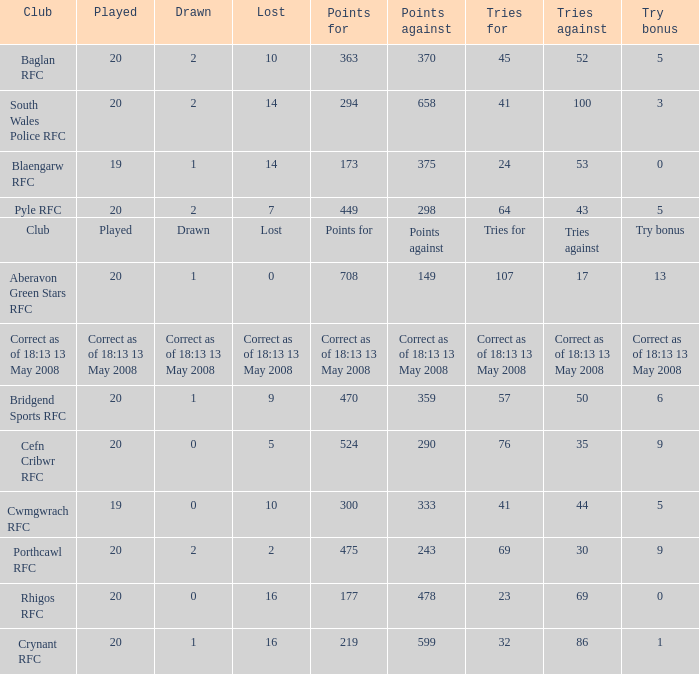Could you parse the entire table as a dict? {'header': ['Club', 'Played', 'Drawn', 'Lost', 'Points for', 'Points against', 'Tries for', 'Tries against', 'Try bonus'], 'rows': [['Baglan RFC', '20', '2', '10', '363', '370', '45', '52', '5'], ['South Wales Police RFC', '20', '2', '14', '294', '658', '41', '100', '3'], ['Blaengarw RFC', '19', '1', '14', '173', '375', '24', '53', '0'], ['Pyle RFC', '20', '2', '7', '449', '298', '64', '43', '5'], ['Club', 'Played', 'Drawn', 'Lost', 'Points for', 'Points against', 'Tries for', 'Tries against', 'Try bonus'], ['Aberavon Green Stars RFC', '20', '1', '0', '708', '149', '107', '17', '13'], ['Correct as of 18:13 13 May 2008', 'Correct as of 18:13 13 May 2008', 'Correct as of 18:13 13 May 2008', 'Correct as of 18:13 13 May 2008', 'Correct as of 18:13 13 May 2008', 'Correct as of 18:13 13 May 2008', 'Correct as of 18:13 13 May 2008', 'Correct as of 18:13 13 May 2008', 'Correct as of 18:13 13 May 2008'], ['Bridgend Sports RFC', '20', '1', '9', '470', '359', '57', '50', '6'], ['Cefn Cribwr RFC', '20', '0', '5', '524', '290', '76', '35', '9'], ['Cwmgwrach RFC', '19', '0', '10', '300', '333', '41', '44', '5'], ['Porthcawl RFC', '20', '2', '2', '475', '243', '69', '30', '9'], ['Rhigos RFC', '20', '0', '16', '177', '478', '23', '69', '0'], ['Crynant RFC', '20', '1', '16', '219', '599', '32', '86', '1']]} What club has a played number of 19, and the lost of 14? Blaengarw RFC. 